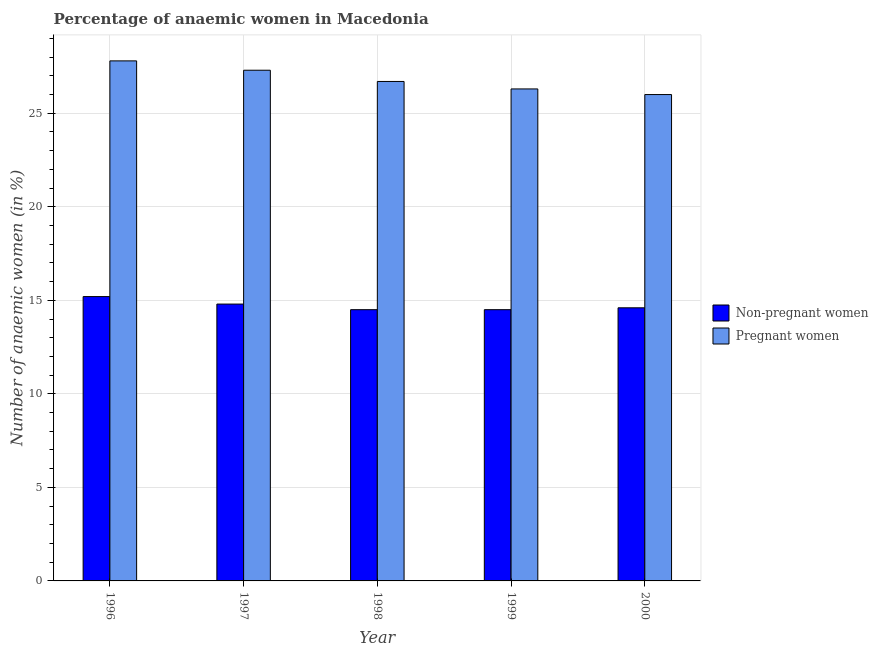Are the number of bars per tick equal to the number of legend labels?
Ensure brevity in your answer.  Yes. How many bars are there on the 4th tick from the right?
Offer a very short reply. 2. What is the label of the 2nd group of bars from the left?
Offer a very short reply. 1997. In how many cases, is the number of bars for a given year not equal to the number of legend labels?
Keep it short and to the point. 0. What is the percentage of pregnant anaemic women in 1996?
Your answer should be very brief. 27.8. Across all years, what is the maximum percentage of non-pregnant anaemic women?
Provide a short and direct response. 15.2. Across all years, what is the minimum percentage of pregnant anaemic women?
Offer a very short reply. 26. In which year was the percentage of non-pregnant anaemic women minimum?
Offer a very short reply. 1998. What is the total percentage of non-pregnant anaemic women in the graph?
Keep it short and to the point. 73.6. What is the difference between the percentage of non-pregnant anaemic women in 1996 and that in 2000?
Offer a very short reply. 0.6. What is the difference between the percentage of non-pregnant anaemic women in 2000 and the percentage of pregnant anaemic women in 1996?
Keep it short and to the point. -0.6. What is the average percentage of non-pregnant anaemic women per year?
Offer a terse response. 14.72. In the year 1999, what is the difference between the percentage of non-pregnant anaemic women and percentage of pregnant anaemic women?
Offer a very short reply. 0. In how many years, is the percentage of non-pregnant anaemic women greater than 21 %?
Your response must be concise. 0. What is the ratio of the percentage of non-pregnant anaemic women in 1996 to that in 1997?
Make the answer very short. 1.03. Is the percentage of non-pregnant anaemic women in 1997 less than that in 2000?
Your answer should be compact. No. Is the difference between the percentage of non-pregnant anaemic women in 1997 and 1999 greater than the difference between the percentage of pregnant anaemic women in 1997 and 1999?
Offer a terse response. No. What is the difference between the highest and the second highest percentage of non-pregnant anaemic women?
Ensure brevity in your answer.  0.4. What is the difference between the highest and the lowest percentage of pregnant anaemic women?
Provide a succinct answer. 1.8. What does the 1st bar from the left in 1998 represents?
Offer a very short reply. Non-pregnant women. What does the 1st bar from the right in 1998 represents?
Provide a short and direct response. Pregnant women. How many bars are there?
Make the answer very short. 10. Are all the bars in the graph horizontal?
Your answer should be very brief. No. How many years are there in the graph?
Your response must be concise. 5. How many legend labels are there?
Provide a succinct answer. 2. What is the title of the graph?
Your answer should be very brief. Percentage of anaemic women in Macedonia. Does "Female labourers" appear as one of the legend labels in the graph?
Offer a terse response. No. What is the label or title of the X-axis?
Your response must be concise. Year. What is the label or title of the Y-axis?
Your response must be concise. Number of anaemic women (in %). What is the Number of anaemic women (in %) of Pregnant women in 1996?
Your answer should be compact. 27.8. What is the Number of anaemic women (in %) of Pregnant women in 1997?
Ensure brevity in your answer.  27.3. What is the Number of anaemic women (in %) of Pregnant women in 1998?
Make the answer very short. 26.7. What is the Number of anaemic women (in %) of Non-pregnant women in 1999?
Make the answer very short. 14.5. What is the Number of anaemic women (in %) of Pregnant women in 1999?
Your response must be concise. 26.3. Across all years, what is the maximum Number of anaemic women (in %) of Pregnant women?
Your answer should be compact. 27.8. Across all years, what is the minimum Number of anaemic women (in %) in Pregnant women?
Provide a short and direct response. 26. What is the total Number of anaemic women (in %) in Non-pregnant women in the graph?
Offer a very short reply. 73.6. What is the total Number of anaemic women (in %) in Pregnant women in the graph?
Offer a very short reply. 134.1. What is the difference between the Number of anaemic women (in %) in Non-pregnant women in 1996 and that in 1997?
Ensure brevity in your answer.  0.4. What is the difference between the Number of anaemic women (in %) in Pregnant women in 1996 and that in 1999?
Offer a very short reply. 1.5. What is the difference between the Number of anaemic women (in %) in Pregnant women in 1997 and that in 1998?
Give a very brief answer. 0.6. What is the difference between the Number of anaemic women (in %) in Non-pregnant women in 1997 and that in 1999?
Provide a succinct answer. 0.3. What is the difference between the Number of anaemic women (in %) in Pregnant women in 1998 and that in 1999?
Offer a terse response. 0.4. What is the difference between the Number of anaemic women (in %) in Non-pregnant women in 1998 and that in 2000?
Give a very brief answer. -0.1. What is the difference between the Number of anaemic women (in %) in Pregnant women in 1999 and that in 2000?
Give a very brief answer. 0.3. What is the difference between the Number of anaemic women (in %) in Non-pregnant women in 1996 and the Number of anaemic women (in %) in Pregnant women in 1998?
Offer a terse response. -11.5. What is the difference between the Number of anaemic women (in %) in Non-pregnant women in 1996 and the Number of anaemic women (in %) in Pregnant women in 1999?
Offer a very short reply. -11.1. What is the difference between the Number of anaemic women (in %) of Non-pregnant women in 1996 and the Number of anaemic women (in %) of Pregnant women in 2000?
Ensure brevity in your answer.  -10.8. What is the difference between the Number of anaemic women (in %) in Non-pregnant women in 1997 and the Number of anaemic women (in %) in Pregnant women in 1998?
Provide a succinct answer. -11.9. What is the difference between the Number of anaemic women (in %) in Non-pregnant women in 1997 and the Number of anaemic women (in %) in Pregnant women in 2000?
Make the answer very short. -11.2. What is the difference between the Number of anaemic women (in %) of Non-pregnant women in 1998 and the Number of anaemic women (in %) of Pregnant women in 1999?
Make the answer very short. -11.8. What is the difference between the Number of anaemic women (in %) in Non-pregnant women in 1998 and the Number of anaemic women (in %) in Pregnant women in 2000?
Your answer should be compact. -11.5. What is the average Number of anaemic women (in %) in Non-pregnant women per year?
Offer a very short reply. 14.72. What is the average Number of anaemic women (in %) of Pregnant women per year?
Provide a short and direct response. 26.82. In the year 1997, what is the difference between the Number of anaemic women (in %) in Non-pregnant women and Number of anaemic women (in %) in Pregnant women?
Ensure brevity in your answer.  -12.5. In the year 1998, what is the difference between the Number of anaemic women (in %) in Non-pregnant women and Number of anaemic women (in %) in Pregnant women?
Offer a very short reply. -12.2. What is the ratio of the Number of anaemic women (in %) in Non-pregnant women in 1996 to that in 1997?
Offer a very short reply. 1.03. What is the ratio of the Number of anaemic women (in %) of Pregnant women in 1996 to that in 1997?
Provide a succinct answer. 1.02. What is the ratio of the Number of anaemic women (in %) of Non-pregnant women in 1996 to that in 1998?
Your answer should be very brief. 1.05. What is the ratio of the Number of anaemic women (in %) in Pregnant women in 1996 to that in 1998?
Keep it short and to the point. 1.04. What is the ratio of the Number of anaemic women (in %) of Non-pregnant women in 1996 to that in 1999?
Give a very brief answer. 1.05. What is the ratio of the Number of anaemic women (in %) of Pregnant women in 1996 to that in 1999?
Provide a short and direct response. 1.06. What is the ratio of the Number of anaemic women (in %) in Non-pregnant women in 1996 to that in 2000?
Ensure brevity in your answer.  1.04. What is the ratio of the Number of anaemic women (in %) in Pregnant women in 1996 to that in 2000?
Ensure brevity in your answer.  1.07. What is the ratio of the Number of anaemic women (in %) of Non-pregnant women in 1997 to that in 1998?
Ensure brevity in your answer.  1.02. What is the ratio of the Number of anaemic women (in %) in Pregnant women in 1997 to that in 1998?
Offer a very short reply. 1.02. What is the ratio of the Number of anaemic women (in %) in Non-pregnant women in 1997 to that in 1999?
Give a very brief answer. 1.02. What is the ratio of the Number of anaemic women (in %) of Pregnant women in 1997 to that in 1999?
Provide a short and direct response. 1.04. What is the ratio of the Number of anaemic women (in %) in Non-pregnant women in 1997 to that in 2000?
Provide a short and direct response. 1.01. What is the ratio of the Number of anaemic women (in %) in Pregnant women in 1998 to that in 1999?
Your answer should be compact. 1.02. What is the ratio of the Number of anaemic women (in %) of Pregnant women in 1998 to that in 2000?
Provide a succinct answer. 1.03. What is the ratio of the Number of anaemic women (in %) in Non-pregnant women in 1999 to that in 2000?
Offer a very short reply. 0.99. What is the ratio of the Number of anaemic women (in %) of Pregnant women in 1999 to that in 2000?
Give a very brief answer. 1.01. What is the difference between the highest and the second highest Number of anaemic women (in %) of Non-pregnant women?
Provide a short and direct response. 0.4. What is the difference between the highest and the second highest Number of anaemic women (in %) of Pregnant women?
Your answer should be compact. 0.5. What is the difference between the highest and the lowest Number of anaemic women (in %) in Non-pregnant women?
Give a very brief answer. 0.7. What is the difference between the highest and the lowest Number of anaemic women (in %) in Pregnant women?
Your answer should be compact. 1.8. 